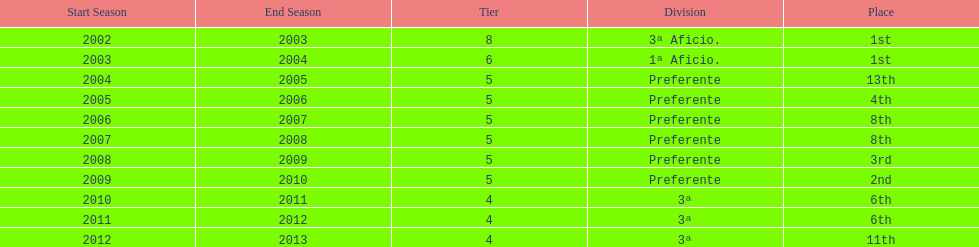How many times did internacional de madrid cf end the season at the top of their division? 2. 